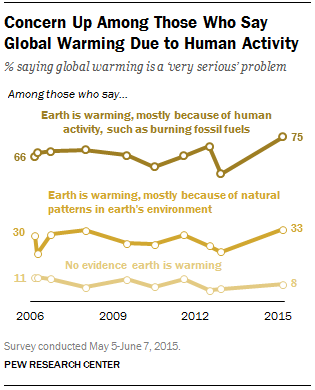Mention a couple of crucial points in this snapshot. The product of all the values in 2015 is 19800. In 2015, the lowest value of graph was 8. 